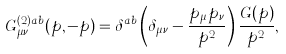Convert formula to latex. <formula><loc_0><loc_0><loc_500><loc_500>G ^ { ( 2 ) a b } _ { \mu \nu } ( p , - p ) = \delta ^ { a b } \left ( \delta _ { \mu \nu } - \frac { p _ { \mu } p _ { \nu } } { p ^ { 2 } } \right ) \frac { G ( p ) } { p ^ { 2 } } ,</formula> 